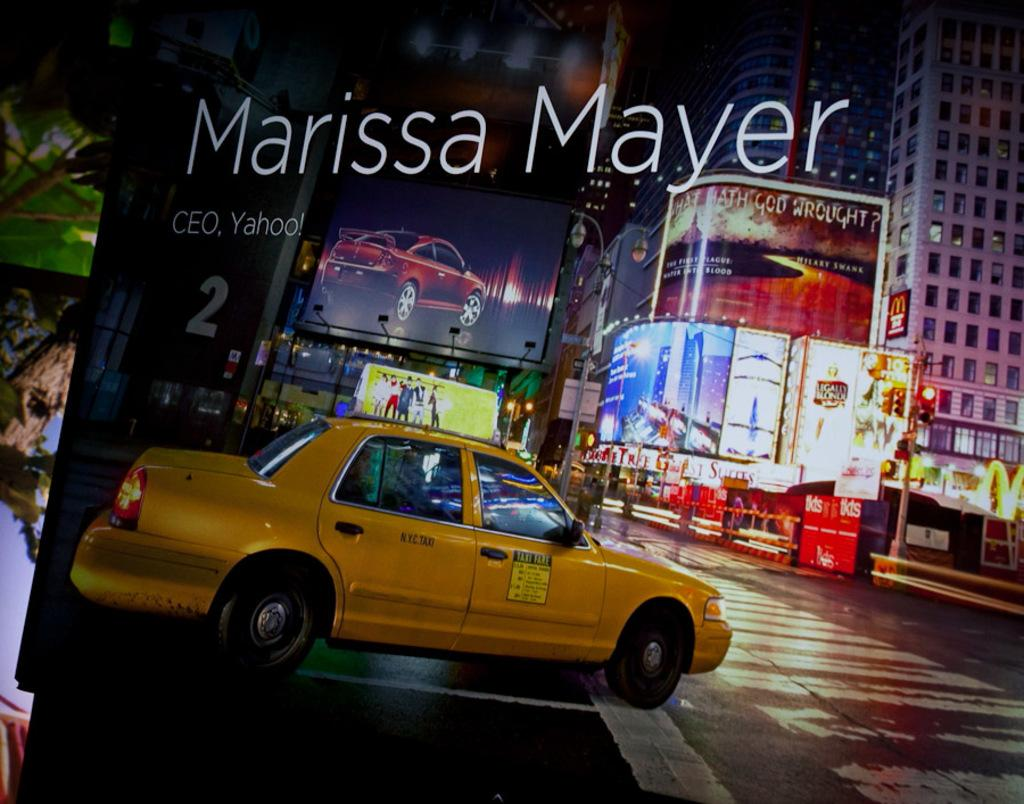<image>
Present a compact description of the photo's key features. A scene of a city street has Marissa Mayer at the top. 